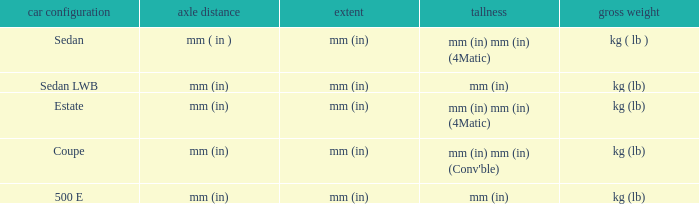What are the lengths of the models that are mm (in) tall? Mm (in), mm (in). 